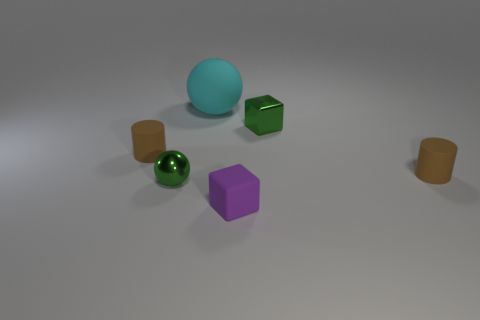Add 2 rubber cubes. How many objects exist? 8 Add 3 big cyan spheres. How many big cyan spheres are left? 4 Add 6 brown cylinders. How many brown cylinders exist? 8 Subtract 0 purple cylinders. How many objects are left? 6 Subtract all small objects. Subtract all shiny blocks. How many objects are left? 0 